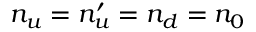<formula> <loc_0><loc_0><loc_500><loc_500>n _ { u } = n _ { u } ^ { \prime } = n _ { d } = n _ { 0 }</formula> 